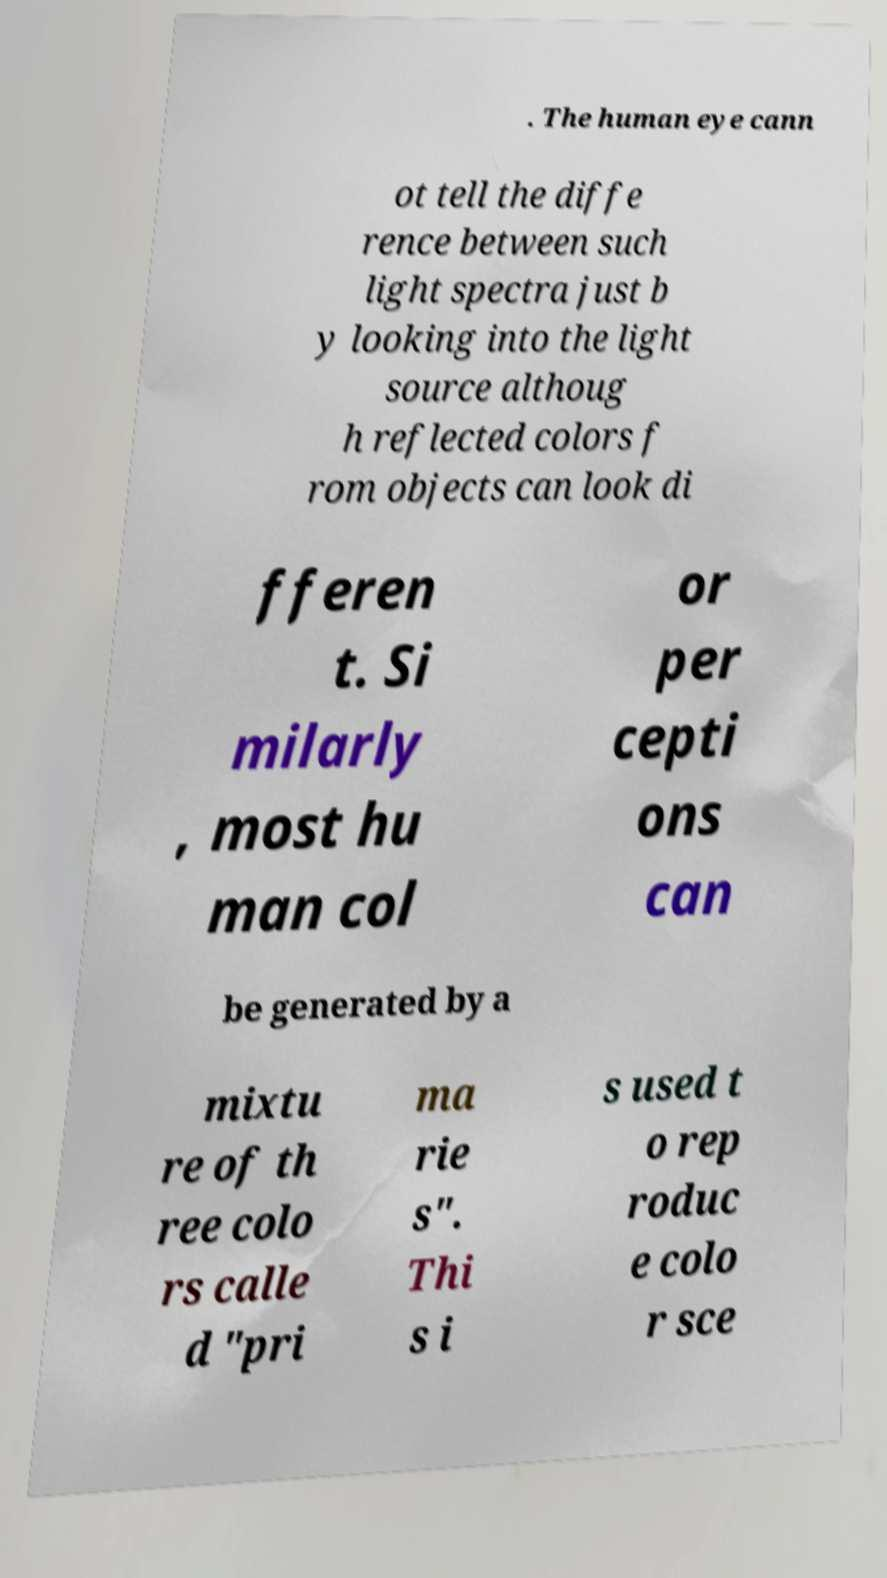There's text embedded in this image that I need extracted. Can you transcribe it verbatim? . The human eye cann ot tell the diffe rence between such light spectra just b y looking into the light source althoug h reflected colors f rom objects can look di fferen t. Si milarly , most hu man col or per cepti ons can be generated by a mixtu re of th ree colo rs calle d "pri ma rie s". Thi s i s used t o rep roduc e colo r sce 